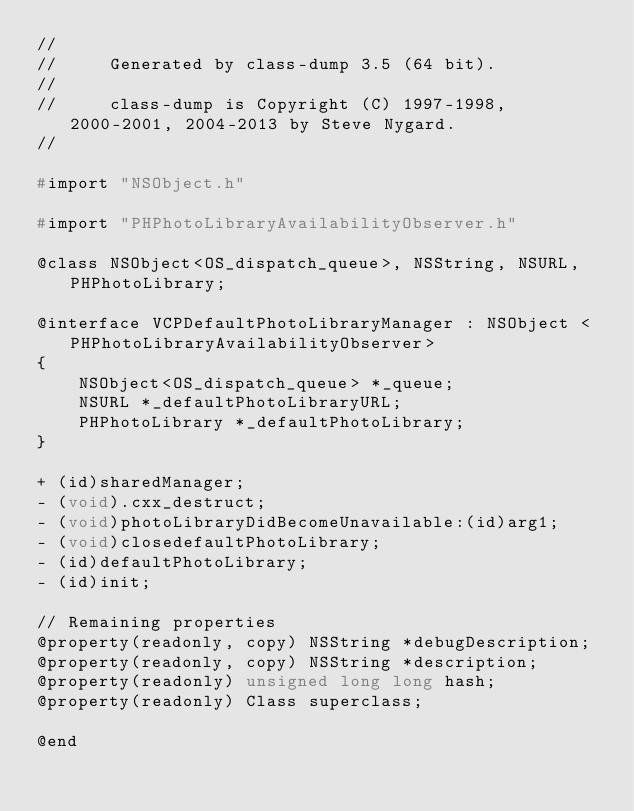<code> <loc_0><loc_0><loc_500><loc_500><_C_>//
//     Generated by class-dump 3.5 (64 bit).
//
//     class-dump is Copyright (C) 1997-1998, 2000-2001, 2004-2013 by Steve Nygard.
//

#import "NSObject.h"

#import "PHPhotoLibraryAvailabilityObserver.h"

@class NSObject<OS_dispatch_queue>, NSString, NSURL, PHPhotoLibrary;

@interface VCPDefaultPhotoLibraryManager : NSObject <PHPhotoLibraryAvailabilityObserver>
{
    NSObject<OS_dispatch_queue> *_queue;
    NSURL *_defaultPhotoLibraryURL;
    PHPhotoLibrary *_defaultPhotoLibrary;
}

+ (id)sharedManager;
- (void).cxx_destruct;
- (void)photoLibraryDidBecomeUnavailable:(id)arg1;
- (void)closedefaultPhotoLibrary;
- (id)defaultPhotoLibrary;
- (id)init;

// Remaining properties
@property(readonly, copy) NSString *debugDescription;
@property(readonly, copy) NSString *description;
@property(readonly) unsigned long long hash;
@property(readonly) Class superclass;

@end

</code> 